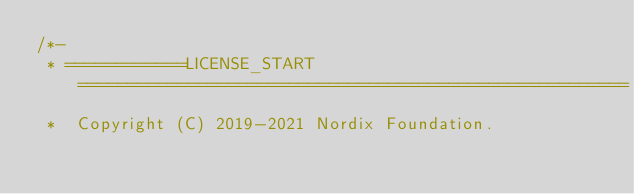Convert code to text. <code><loc_0><loc_0><loc_500><loc_500><_Java_>/*-
 * ============LICENSE_START=======================================================
 *  Copyright (C) 2019-2021 Nordix Foundation.</code> 